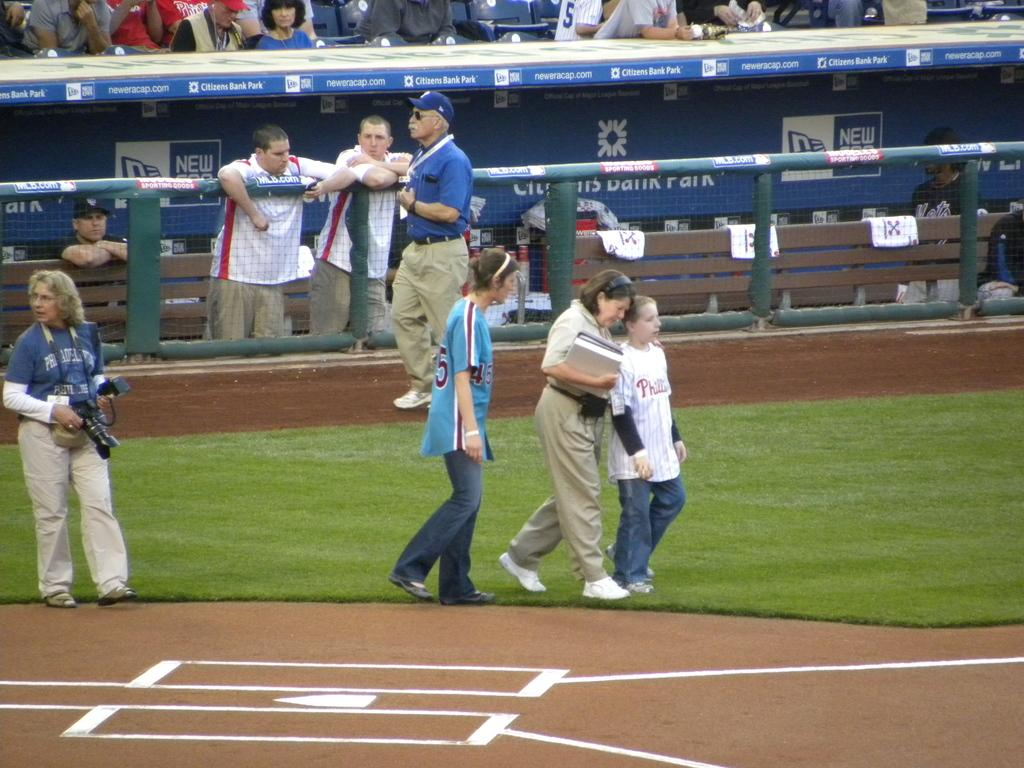<image>
Summarize the visual content of the image. Sports players on a field, the words Citizens Bank Park are visible behind them 